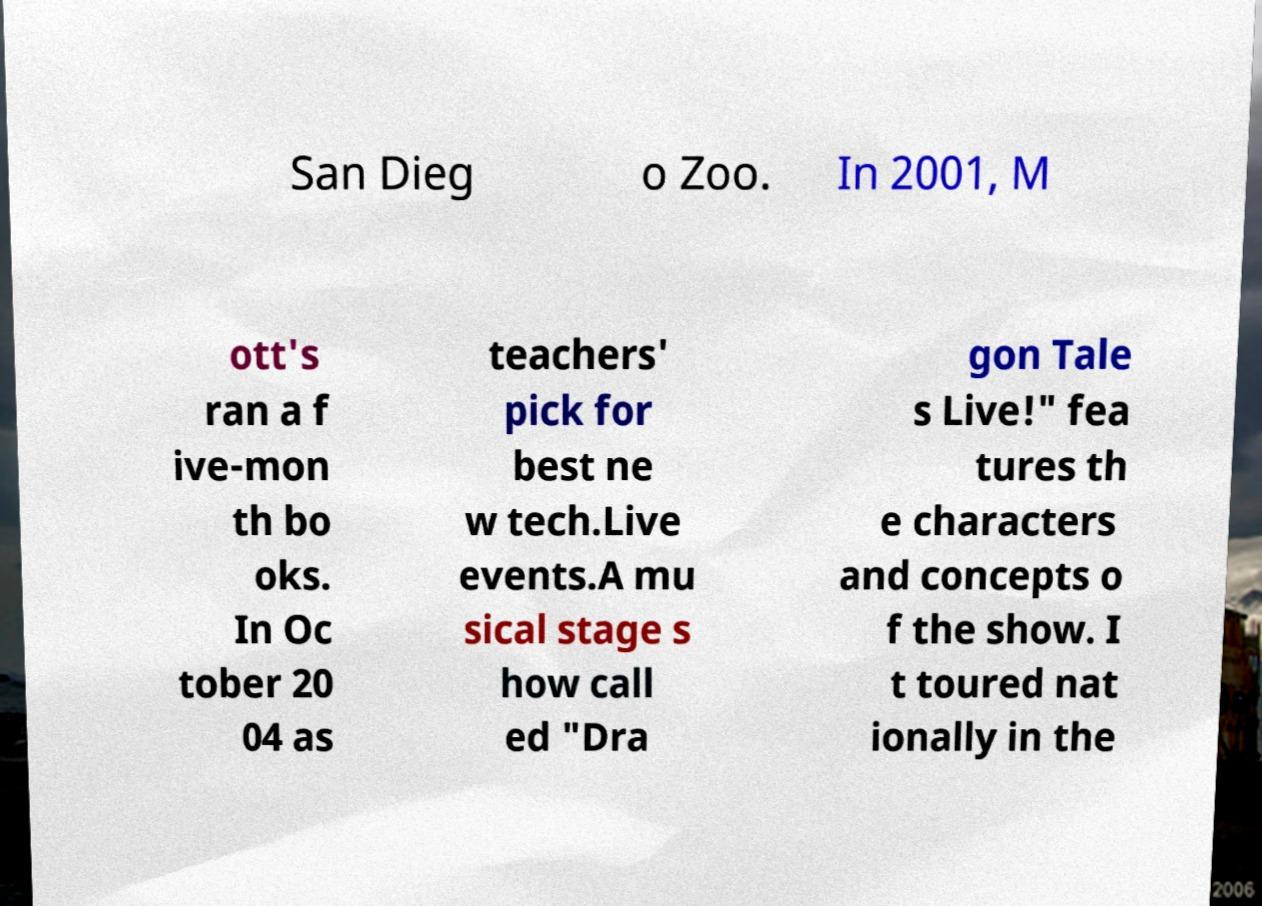What messages or text are displayed in this image? I need them in a readable, typed format. San Dieg o Zoo. In 2001, M ott's ran a f ive-mon th bo oks. In Oc tober 20 04 as teachers' pick for best ne w tech.Live events.A mu sical stage s how call ed "Dra gon Tale s Live!" fea tures th e characters and concepts o f the show. I t toured nat ionally in the 